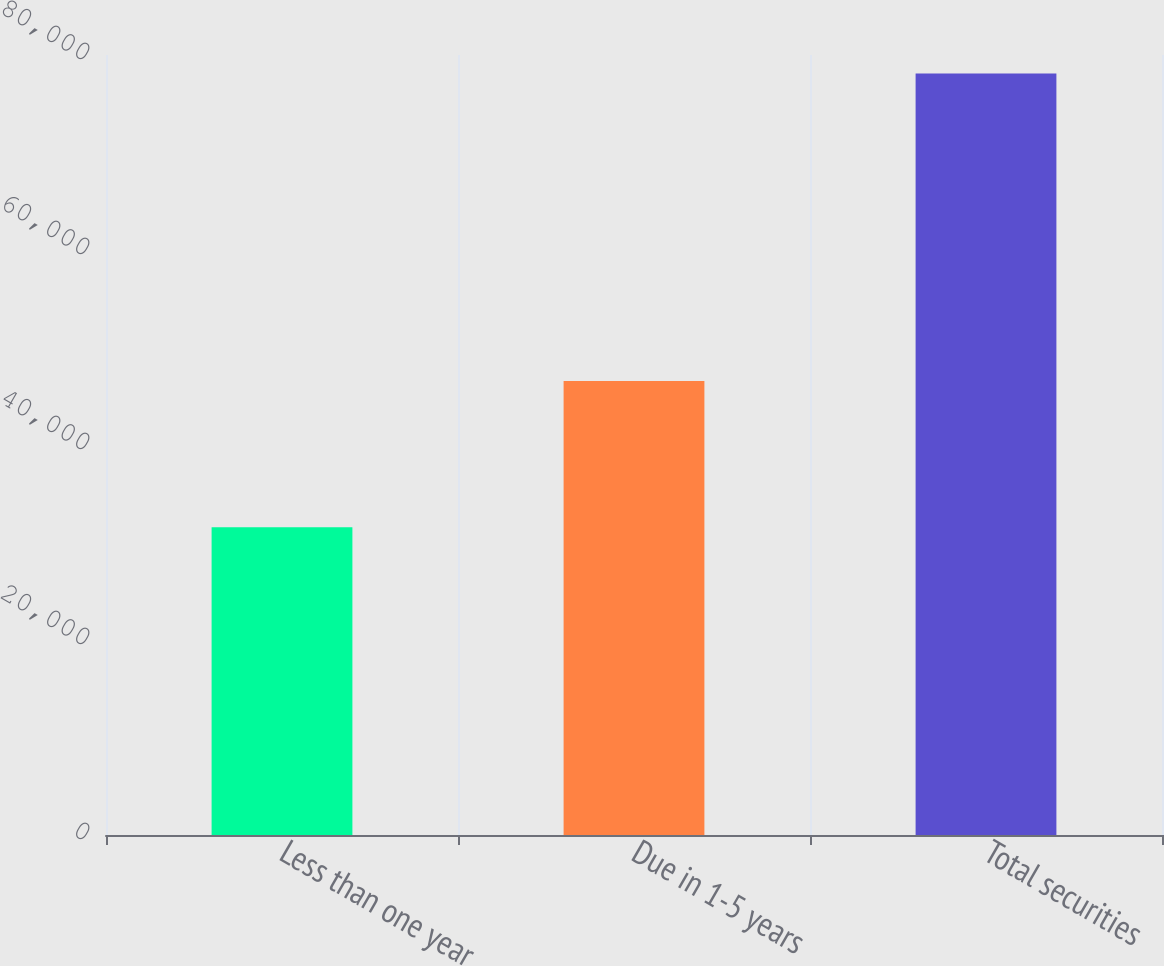Convert chart to OTSL. <chart><loc_0><loc_0><loc_500><loc_500><bar_chart><fcel>Less than one year<fcel>Due in 1-5 years<fcel>Total securities<nl><fcel>31554<fcel>46556<fcel>78110<nl></chart> 